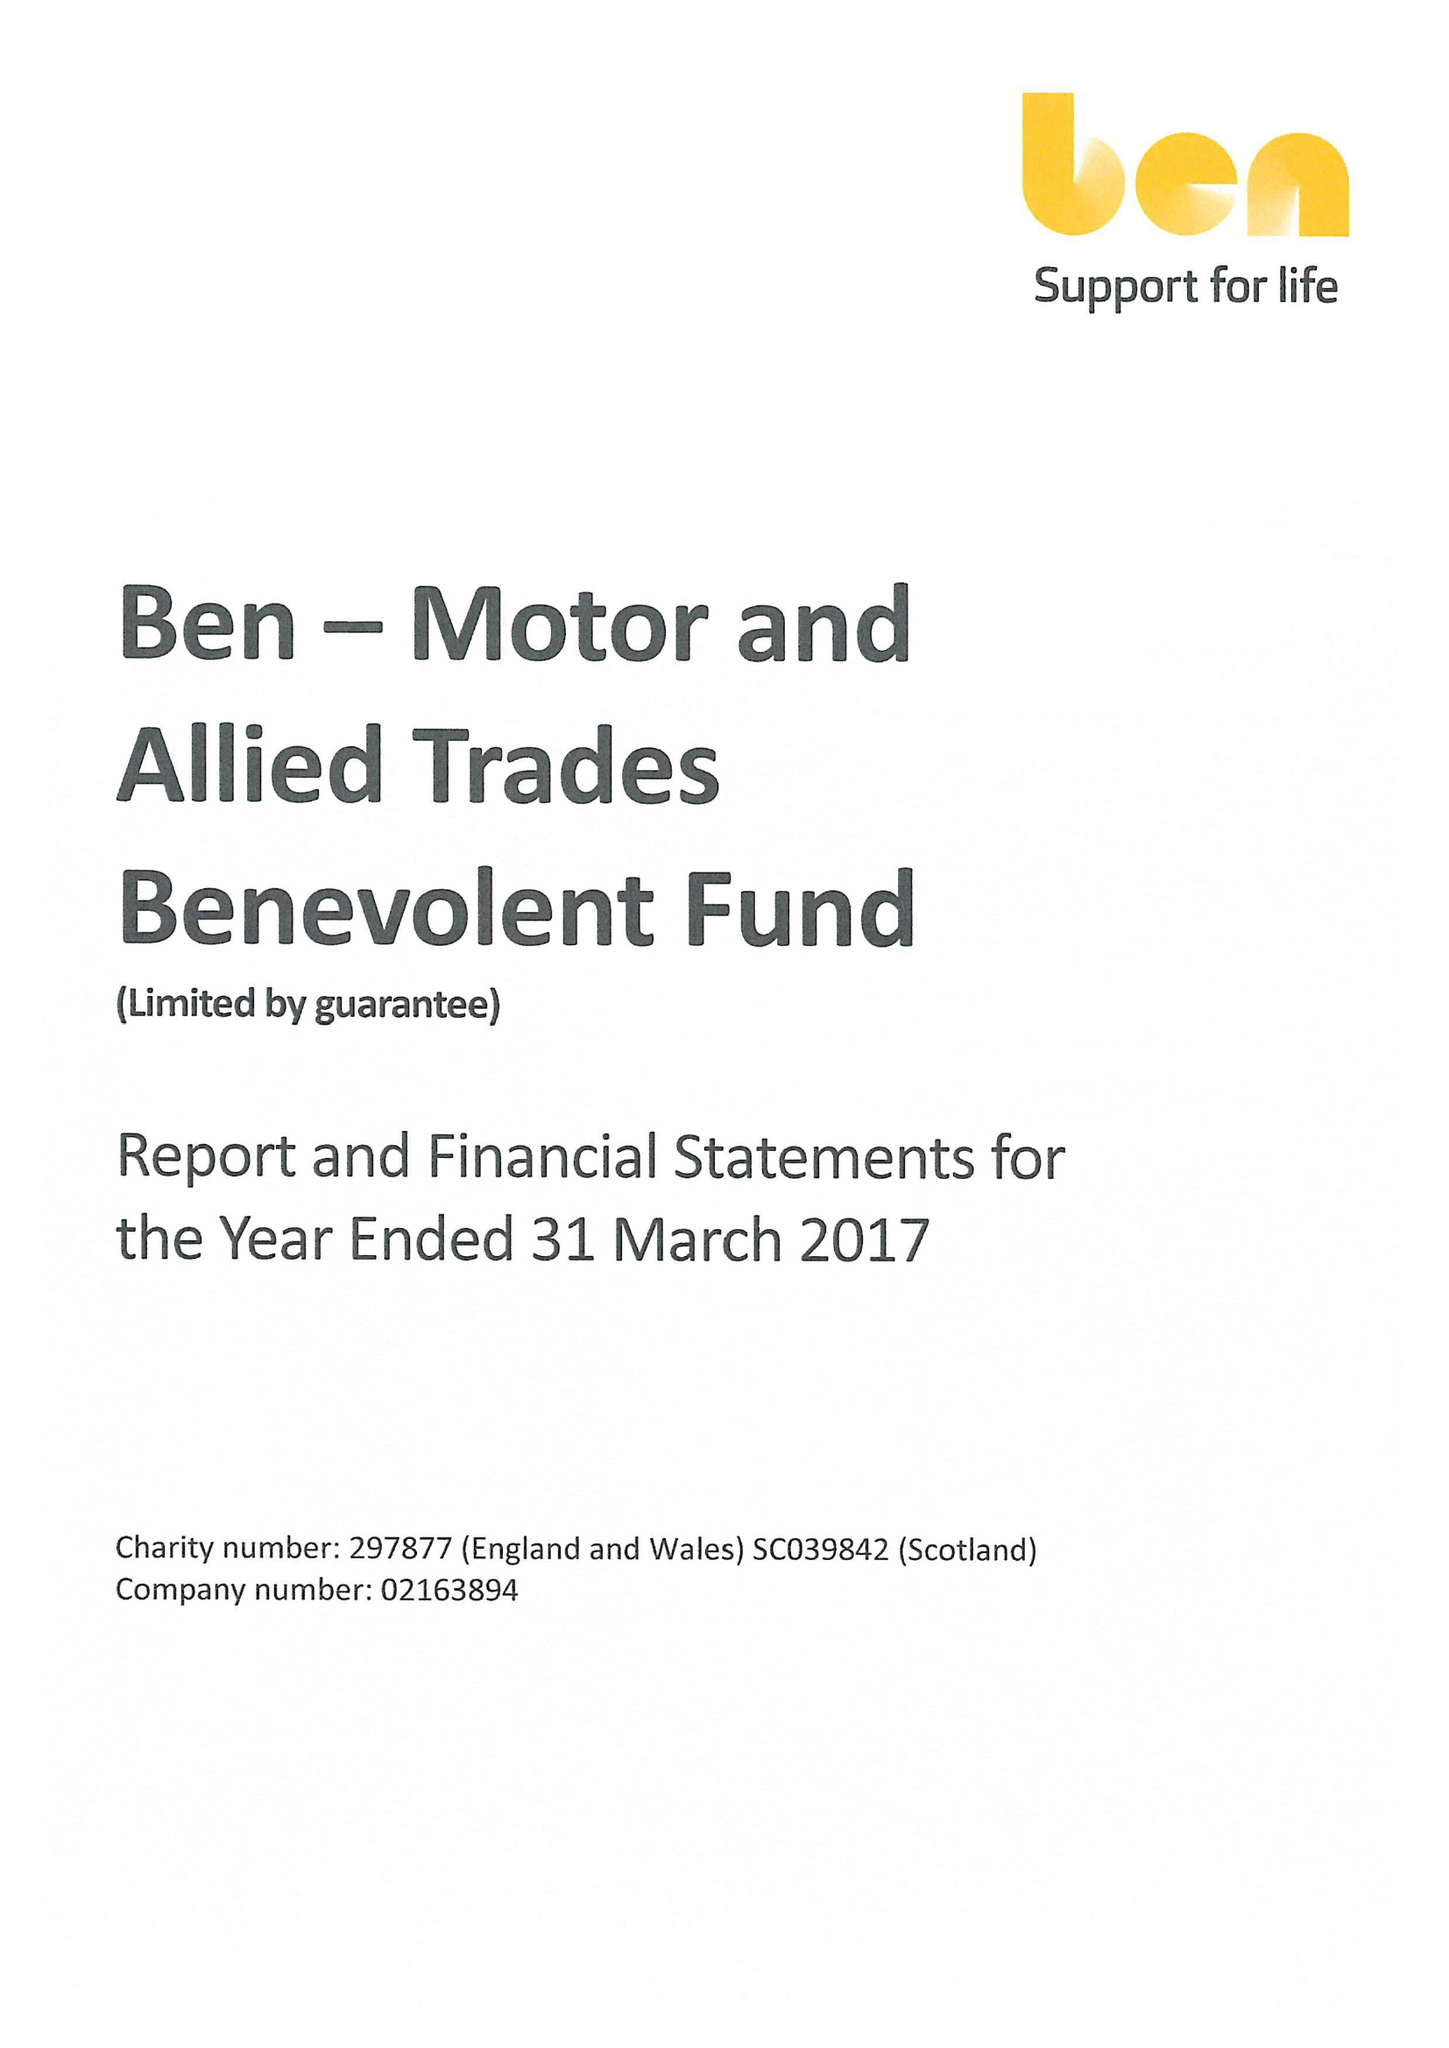What is the value for the spending_annually_in_british_pounds?
Answer the question using a single word or phrase. 22381000.00 